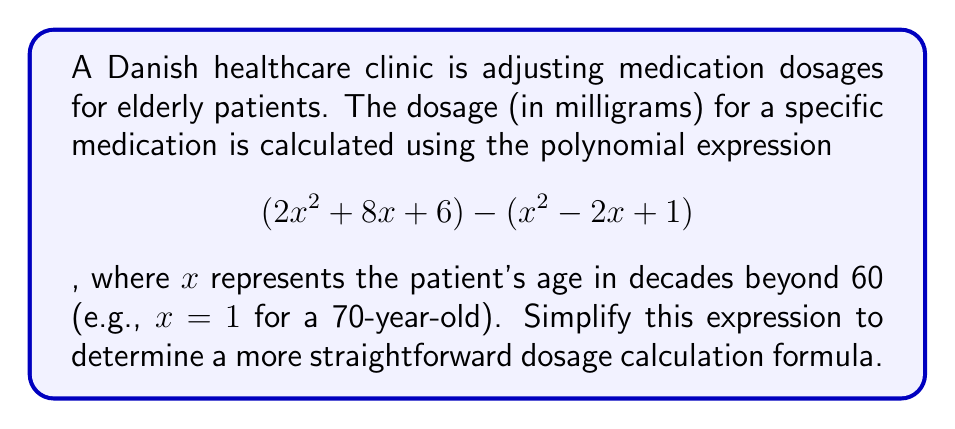Teach me how to tackle this problem. To simplify this polynomial expression, we need to subtract the second polynomial from the first. Let's approach this step-by-step:

1) First, let's identify the polynomials:
   Polynomial 1: $2x^2 + 8x + 6$
   Polynomial 2: $x^2 - 2x + 1$

2) When subtracting polynomials, we subtract the coefficients of like terms:

   For $x^2$ terms:
   $2x^2 - x^2 = x^2$

   For $x$ terms:
   $8x - (-2x) = 8x + 2x = 10x$

   For constant terms:
   $6 - 1 = 5$

3) Combining these results, we get:

   $x^2 + 10x + 5$

This simplified polynomial represents the new dosage calculation formula.
Answer: $x^2 + 10x + 5$ 